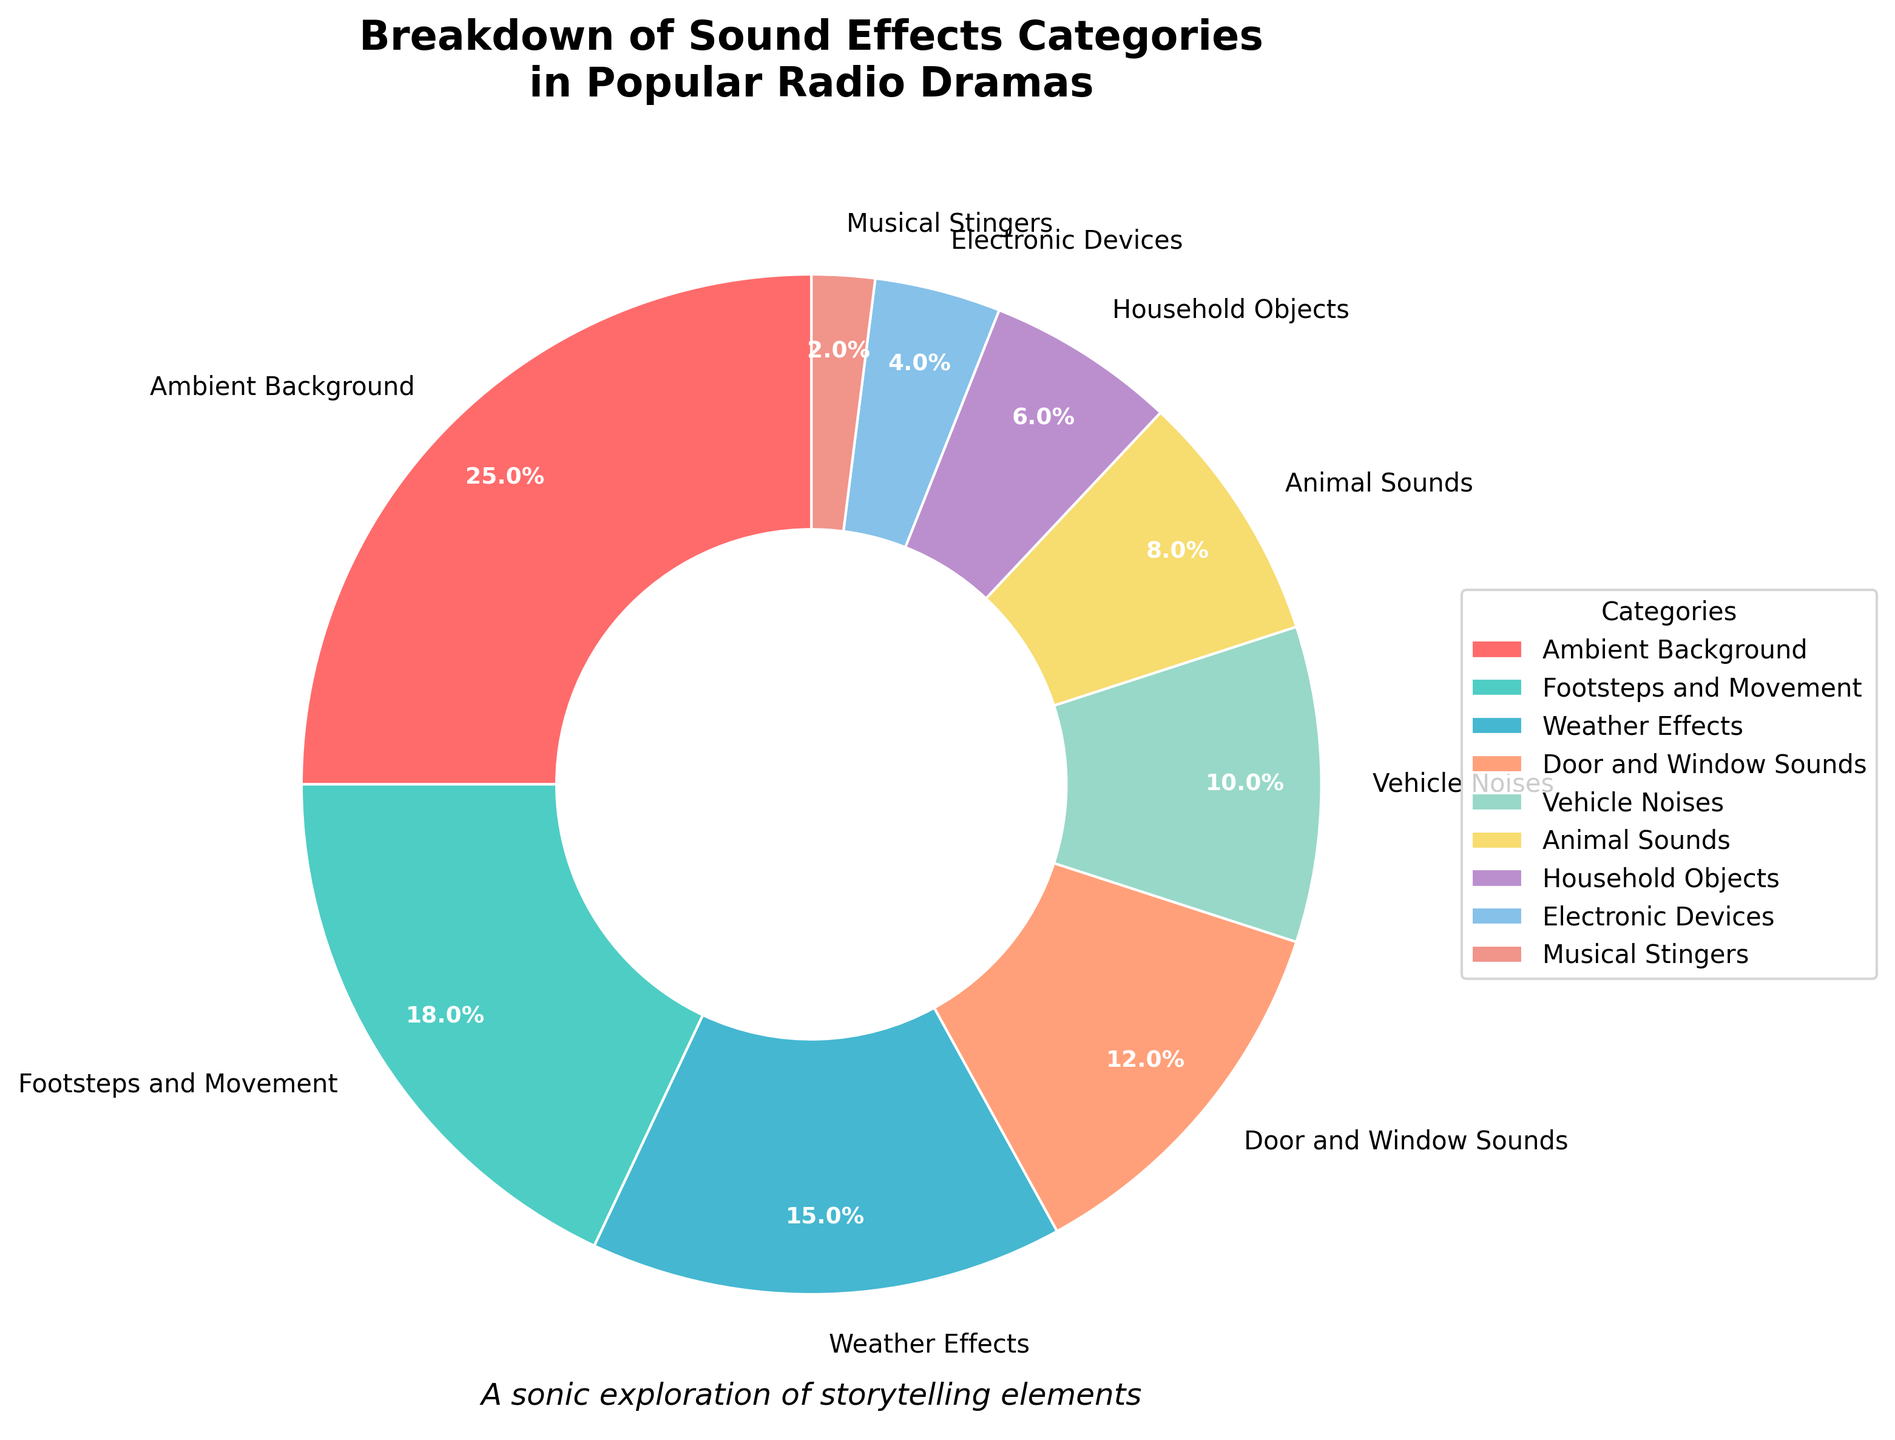Which category has the highest percentage? To determine the category with the highest percentage, identify the largest segment in the pie chart. The "Ambient Background" segment is the largest at 25%.
Answer: Ambient Background What is the total percentage for "Footsteps and Movement" and "Weather Effects" combined? Add the percentages of "Footsteps and Movement" (18%) and "Weather Effects" (15%) to get the combined total. 18% + 15% = 33%.
Answer: 33% Which category has a lower percentage: "Vehicle Noises" or "Household Objects"? Compare the percentages of "Vehicle Noises" (10%) and "Household Objects" (6%). "Household Objects" has a lower percentage.
Answer: Household Objects Is the percentage of "Electronic Devices" greater than "Musical Stingers"? Compare the percentages: "Electronic Devices" is 4% and "Musical Stingers" is 2%. 4% is greater than 2%.
Answer: Yes What is the combined percentage of all categories related to animal sounds, household objects, and musical stingers? Add the percentages of "Animal Sounds" (8%), "Household Objects" (6%), and "Musical Stingers" (2%) to get the combined total. 8% + 6% + 2% = 16%.
Answer: 16% Which categories have a percentage greater than 12%? Identify the segments with percentages above 12%: "Ambient Background" (25%), "Footsteps and Movement" (18%), and "Weather Effects" (15%).
Answer: Ambient Background, Footsteps and Movement, Weather Effects What is the ratio of "Door and Window Sounds" to "Animal Sounds"? Calculate the ratio by dividing the percentage of "Door and Window Sounds" (12%) by the percentage of "Animal Sounds" (8%). 12% ÷ 8% = 1.5.
Answer: 1.5 Are "Weather Effects" and "Vehicle Noises" combined equal to the percentage of "Ambient Background"? Sum the percentages of "Weather Effects" (15%) and "Vehicle Noises" (10%) and compare to "Ambient Background" (25%). 15% + 10% = 25%, which equals 25%.
Answer: Yes 